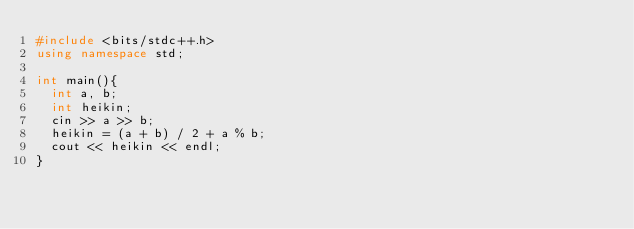Convert code to text. <code><loc_0><loc_0><loc_500><loc_500><_C++_>#include <bits/stdc++.h>
using namespace std;

int main(){
  int a, b;
  int heikin;
  cin >> a >> b;
  heikin = (a + b) / 2 + a % b;
  cout << heikin << endl;
}</code> 